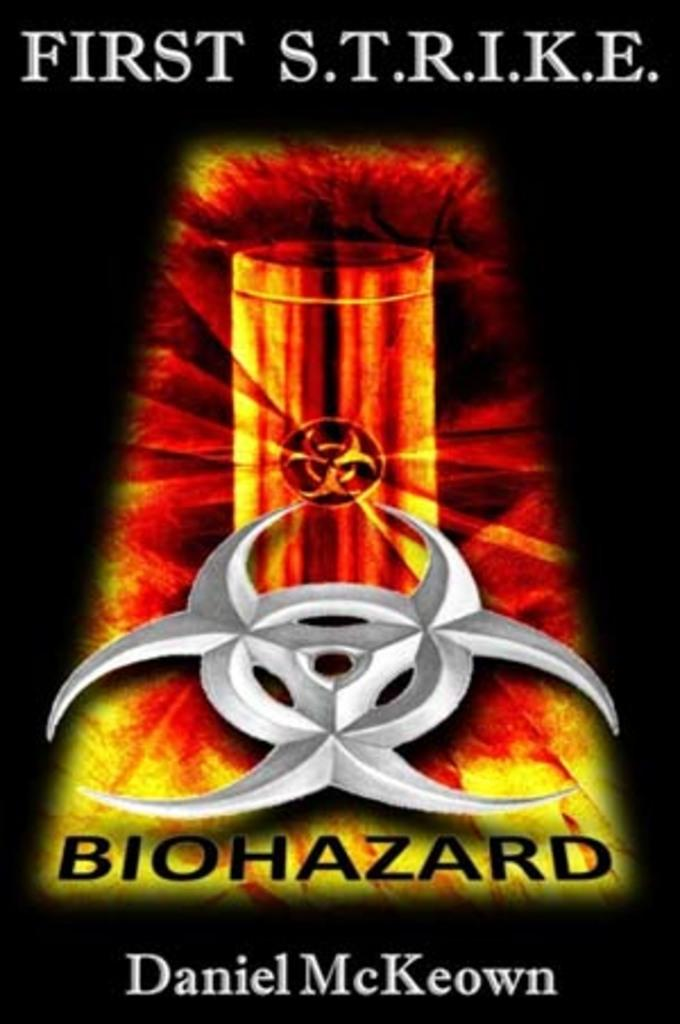<image>
Relay a brief, clear account of the picture shown. The cover of a book titled First S.T.R.I.K.E prominently displaying a biohazard symbol 